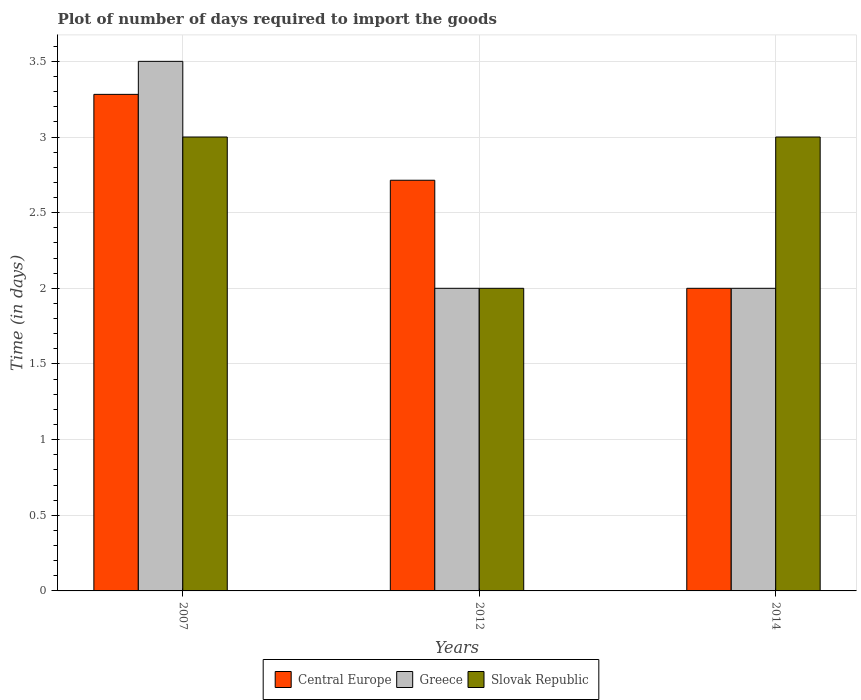How many groups of bars are there?
Your answer should be compact. 3. Are the number of bars on each tick of the X-axis equal?
Keep it short and to the point. Yes. How many bars are there on the 3rd tick from the left?
Provide a short and direct response. 3. What is the label of the 1st group of bars from the left?
Provide a short and direct response. 2007. What is the time required to import goods in Slovak Republic in 2014?
Your answer should be compact. 3. Across all years, what is the maximum time required to import goods in Slovak Republic?
Offer a very short reply. 3. Across all years, what is the minimum time required to import goods in Central Europe?
Provide a succinct answer. 2. In which year was the time required to import goods in Greece maximum?
Make the answer very short. 2007. In which year was the time required to import goods in Slovak Republic minimum?
Make the answer very short. 2012. What is the total time required to import goods in Central Europe in the graph?
Make the answer very short. 8. What is the difference between the time required to import goods in Central Europe in 2014 and the time required to import goods in Slovak Republic in 2012?
Give a very brief answer. 0. What is the average time required to import goods in Slovak Republic per year?
Offer a terse response. 2.67. What is the ratio of the time required to import goods in Slovak Republic in 2007 to that in 2012?
Make the answer very short. 1.5. Is the difference between the time required to import goods in Slovak Republic in 2007 and 2014 greater than the difference between the time required to import goods in Greece in 2007 and 2014?
Keep it short and to the point. No. What is the difference between the highest and the second highest time required to import goods in Slovak Republic?
Keep it short and to the point. 0. What does the 2nd bar from the left in 2012 represents?
Provide a short and direct response. Greece. What does the 1st bar from the right in 2007 represents?
Ensure brevity in your answer.  Slovak Republic. Is it the case that in every year, the sum of the time required to import goods in Greece and time required to import goods in Central Europe is greater than the time required to import goods in Slovak Republic?
Your answer should be compact. Yes. How many bars are there?
Provide a succinct answer. 9. Does the graph contain grids?
Your response must be concise. Yes. What is the title of the graph?
Give a very brief answer. Plot of number of days required to import the goods. What is the label or title of the X-axis?
Your response must be concise. Years. What is the label or title of the Y-axis?
Keep it short and to the point. Time (in days). What is the Time (in days) in Central Europe in 2007?
Provide a succinct answer. 3.28. What is the Time (in days) in Slovak Republic in 2007?
Provide a succinct answer. 3. What is the Time (in days) of Central Europe in 2012?
Keep it short and to the point. 2.71. What is the Time (in days) in Slovak Republic in 2012?
Offer a terse response. 2. What is the Time (in days) of Slovak Republic in 2014?
Keep it short and to the point. 3. Across all years, what is the maximum Time (in days) of Central Europe?
Make the answer very short. 3.28. Across all years, what is the maximum Time (in days) in Greece?
Provide a short and direct response. 3.5. Across all years, what is the maximum Time (in days) in Slovak Republic?
Make the answer very short. 3. Across all years, what is the minimum Time (in days) of Central Europe?
Your answer should be very brief. 2. Across all years, what is the minimum Time (in days) in Slovak Republic?
Your response must be concise. 2. What is the total Time (in days) in Central Europe in the graph?
Offer a terse response. 8. What is the total Time (in days) of Slovak Republic in the graph?
Offer a very short reply. 8. What is the difference between the Time (in days) in Central Europe in 2007 and that in 2012?
Offer a terse response. 0.57. What is the difference between the Time (in days) of Greece in 2007 and that in 2012?
Offer a terse response. 1.5. What is the difference between the Time (in days) of Slovak Republic in 2007 and that in 2012?
Give a very brief answer. 1. What is the difference between the Time (in days) of Central Europe in 2007 and that in 2014?
Provide a succinct answer. 1.28. What is the difference between the Time (in days) of Greece in 2007 and that in 2014?
Your answer should be compact. 1.5. What is the difference between the Time (in days) of Central Europe in 2012 and that in 2014?
Your response must be concise. 0.71. What is the difference between the Time (in days) of Slovak Republic in 2012 and that in 2014?
Your response must be concise. -1. What is the difference between the Time (in days) of Central Europe in 2007 and the Time (in days) of Greece in 2012?
Provide a short and direct response. 1.28. What is the difference between the Time (in days) of Central Europe in 2007 and the Time (in days) of Slovak Republic in 2012?
Your answer should be very brief. 1.28. What is the difference between the Time (in days) in Greece in 2007 and the Time (in days) in Slovak Republic in 2012?
Provide a short and direct response. 1.5. What is the difference between the Time (in days) in Central Europe in 2007 and the Time (in days) in Greece in 2014?
Keep it short and to the point. 1.28. What is the difference between the Time (in days) in Central Europe in 2007 and the Time (in days) in Slovak Republic in 2014?
Keep it short and to the point. 0.28. What is the difference between the Time (in days) of Greece in 2007 and the Time (in days) of Slovak Republic in 2014?
Keep it short and to the point. 0.5. What is the difference between the Time (in days) in Central Europe in 2012 and the Time (in days) in Slovak Republic in 2014?
Provide a short and direct response. -0.29. What is the average Time (in days) in Central Europe per year?
Your response must be concise. 2.67. What is the average Time (in days) of Slovak Republic per year?
Provide a short and direct response. 2.67. In the year 2007, what is the difference between the Time (in days) of Central Europe and Time (in days) of Greece?
Offer a very short reply. -0.22. In the year 2007, what is the difference between the Time (in days) in Central Europe and Time (in days) in Slovak Republic?
Keep it short and to the point. 0.28. In the year 2014, what is the difference between the Time (in days) in Central Europe and Time (in days) in Greece?
Provide a short and direct response. 0. In the year 2014, what is the difference between the Time (in days) in Central Europe and Time (in days) in Slovak Republic?
Ensure brevity in your answer.  -1. What is the ratio of the Time (in days) in Central Europe in 2007 to that in 2012?
Provide a short and direct response. 1.21. What is the ratio of the Time (in days) of Central Europe in 2007 to that in 2014?
Your answer should be compact. 1.64. What is the ratio of the Time (in days) in Greece in 2007 to that in 2014?
Make the answer very short. 1.75. What is the ratio of the Time (in days) in Central Europe in 2012 to that in 2014?
Ensure brevity in your answer.  1.36. What is the ratio of the Time (in days) of Greece in 2012 to that in 2014?
Give a very brief answer. 1. What is the ratio of the Time (in days) of Slovak Republic in 2012 to that in 2014?
Give a very brief answer. 0.67. What is the difference between the highest and the second highest Time (in days) in Central Europe?
Make the answer very short. 0.57. What is the difference between the highest and the second highest Time (in days) of Greece?
Your answer should be compact. 1.5. What is the difference between the highest and the second highest Time (in days) in Slovak Republic?
Offer a terse response. 0. What is the difference between the highest and the lowest Time (in days) of Central Europe?
Offer a very short reply. 1.28. 